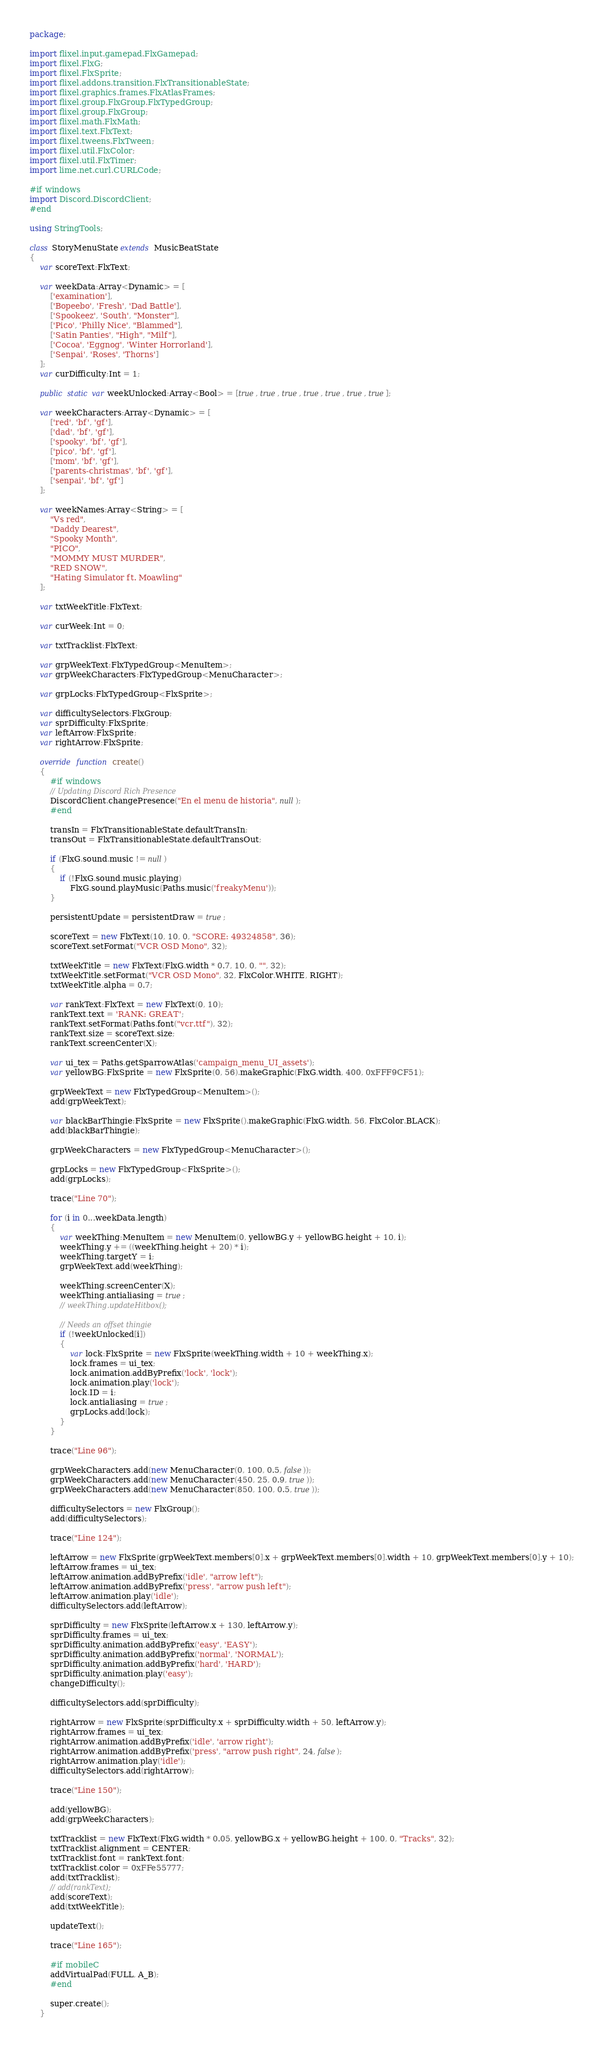<code> <loc_0><loc_0><loc_500><loc_500><_Haxe_>package;

import flixel.input.gamepad.FlxGamepad;
import flixel.FlxG;
import flixel.FlxSprite;
import flixel.addons.transition.FlxTransitionableState;
import flixel.graphics.frames.FlxAtlasFrames;
import flixel.group.FlxGroup.FlxTypedGroup;
import flixel.group.FlxGroup;
import flixel.math.FlxMath;
import flixel.text.FlxText;
import flixel.tweens.FlxTween;
import flixel.util.FlxColor;
import flixel.util.FlxTimer;
import lime.net.curl.CURLCode;

#if windows
import Discord.DiscordClient;
#end

using StringTools;

class StoryMenuState extends MusicBeatState
{
	var scoreText:FlxText;

	var weekData:Array<Dynamic> = [
		['examination'],
		['Bopeebo', 'Fresh', 'Dad Battle'],
		['Spookeez', 'South', "Monster"],
		['Pico', 'Philly Nice', "Blammed"],
		['Satin Panties', "High", "Milf"],
		['Cocoa', 'Eggnog', 'Winter Horrorland'],
		['Senpai', 'Roses', 'Thorns']
	];
	var curDifficulty:Int = 1;

	public static var weekUnlocked:Array<Bool> = [true, true, true, true, true, true, true];

	var weekCharacters:Array<Dynamic> = [
		['red', 'bf', 'gf'],
		['dad', 'bf', 'gf'],
		['spooky', 'bf', 'gf'],
		['pico', 'bf', 'gf'],
		['mom', 'bf', 'gf'],
		['parents-christmas', 'bf', 'gf'],
		['senpai', 'bf', 'gf']
	];

	var weekNames:Array<String> = [
		"Vs red",
		"Daddy Dearest",
		"Spooky Month",
		"PICO",
		"MOMMY MUST MURDER",
		"RED SNOW",
		"Hating Simulator ft. Moawling"
	];

	var txtWeekTitle:FlxText;

	var curWeek:Int = 0;

	var txtTracklist:FlxText;

	var grpWeekText:FlxTypedGroup<MenuItem>;
	var grpWeekCharacters:FlxTypedGroup<MenuCharacter>;

	var grpLocks:FlxTypedGroup<FlxSprite>;

	var difficultySelectors:FlxGroup;
	var sprDifficulty:FlxSprite;
	var leftArrow:FlxSprite;
	var rightArrow:FlxSprite;

	override function create()
	{
		#if windows
		// Updating Discord Rich Presence
		DiscordClient.changePresence("En el menu de historia", null);
		#end

		transIn = FlxTransitionableState.defaultTransIn;
		transOut = FlxTransitionableState.defaultTransOut;

		if (FlxG.sound.music != null)
		{
			if (!FlxG.sound.music.playing)
				FlxG.sound.playMusic(Paths.music('freakyMenu'));
		}

		persistentUpdate = persistentDraw = true;

		scoreText = new FlxText(10, 10, 0, "SCORE: 49324858", 36);
		scoreText.setFormat("VCR OSD Mono", 32);

		txtWeekTitle = new FlxText(FlxG.width * 0.7, 10, 0, "", 32);
		txtWeekTitle.setFormat("VCR OSD Mono", 32, FlxColor.WHITE, RIGHT);
		txtWeekTitle.alpha = 0.7;

		var rankText:FlxText = new FlxText(0, 10);
		rankText.text = 'RANK: GREAT';
		rankText.setFormat(Paths.font("vcr.ttf"), 32);
		rankText.size = scoreText.size;
		rankText.screenCenter(X);

		var ui_tex = Paths.getSparrowAtlas('campaign_menu_UI_assets');
		var yellowBG:FlxSprite = new FlxSprite(0, 56).makeGraphic(FlxG.width, 400, 0xFFF9CF51);

		grpWeekText = new FlxTypedGroup<MenuItem>();
		add(grpWeekText);

		var blackBarThingie:FlxSprite = new FlxSprite().makeGraphic(FlxG.width, 56, FlxColor.BLACK);
		add(blackBarThingie);

		grpWeekCharacters = new FlxTypedGroup<MenuCharacter>();

		grpLocks = new FlxTypedGroup<FlxSprite>();
		add(grpLocks);

		trace("Line 70");

		for (i in 0...weekData.length)
		{
			var weekThing:MenuItem = new MenuItem(0, yellowBG.y + yellowBG.height + 10, i);
			weekThing.y += ((weekThing.height + 20) * i);
			weekThing.targetY = i;
			grpWeekText.add(weekThing);

			weekThing.screenCenter(X);
			weekThing.antialiasing = true;
			// weekThing.updateHitbox();

			// Needs an offset thingie
			if (!weekUnlocked[i])
			{
				var lock:FlxSprite = new FlxSprite(weekThing.width + 10 + weekThing.x);
				lock.frames = ui_tex;
				lock.animation.addByPrefix('lock', 'lock');
				lock.animation.play('lock');
				lock.ID = i;
				lock.antialiasing = true;
				grpLocks.add(lock);
			}
		}

		trace("Line 96");

		grpWeekCharacters.add(new MenuCharacter(0, 100, 0.5, false));
		grpWeekCharacters.add(new MenuCharacter(450, 25, 0.9, true));
		grpWeekCharacters.add(new MenuCharacter(850, 100, 0.5, true));

		difficultySelectors = new FlxGroup();
		add(difficultySelectors);

		trace("Line 124");

		leftArrow = new FlxSprite(grpWeekText.members[0].x + grpWeekText.members[0].width + 10, grpWeekText.members[0].y + 10);
		leftArrow.frames = ui_tex;
		leftArrow.animation.addByPrefix('idle', "arrow left");
		leftArrow.animation.addByPrefix('press', "arrow push left");
		leftArrow.animation.play('idle');
		difficultySelectors.add(leftArrow);

		sprDifficulty = new FlxSprite(leftArrow.x + 130, leftArrow.y);
		sprDifficulty.frames = ui_tex;
		sprDifficulty.animation.addByPrefix('easy', 'EASY');
		sprDifficulty.animation.addByPrefix('normal', 'NORMAL');
		sprDifficulty.animation.addByPrefix('hard', 'HARD');
		sprDifficulty.animation.play('easy');
		changeDifficulty();

		difficultySelectors.add(sprDifficulty);

		rightArrow = new FlxSprite(sprDifficulty.x + sprDifficulty.width + 50, leftArrow.y);
		rightArrow.frames = ui_tex;
		rightArrow.animation.addByPrefix('idle', 'arrow right');
		rightArrow.animation.addByPrefix('press', "arrow push right", 24, false);
		rightArrow.animation.play('idle');
		difficultySelectors.add(rightArrow);

		trace("Line 150");

		add(yellowBG);
		add(grpWeekCharacters);

		txtTracklist = new FlxText(FlxG.width * 0.05, yellowBG.x + yellowBG.height + 100, 0, "Tracks", 32);
		txtTracklist.alignment = CENTER;
		txtTracklist.font = rankText.font;
		txtTracklist.color = 0xFFe55777;
		add(txtTracklist);
		// add(rankText);
		add(scoreText);
		add(txtWeekTitle);

		updateText();

		trace("Line 165");

		#if mobileC
		addVirtualPad(FULL, A_B);
		#end

		super.create();
	}
</code> 